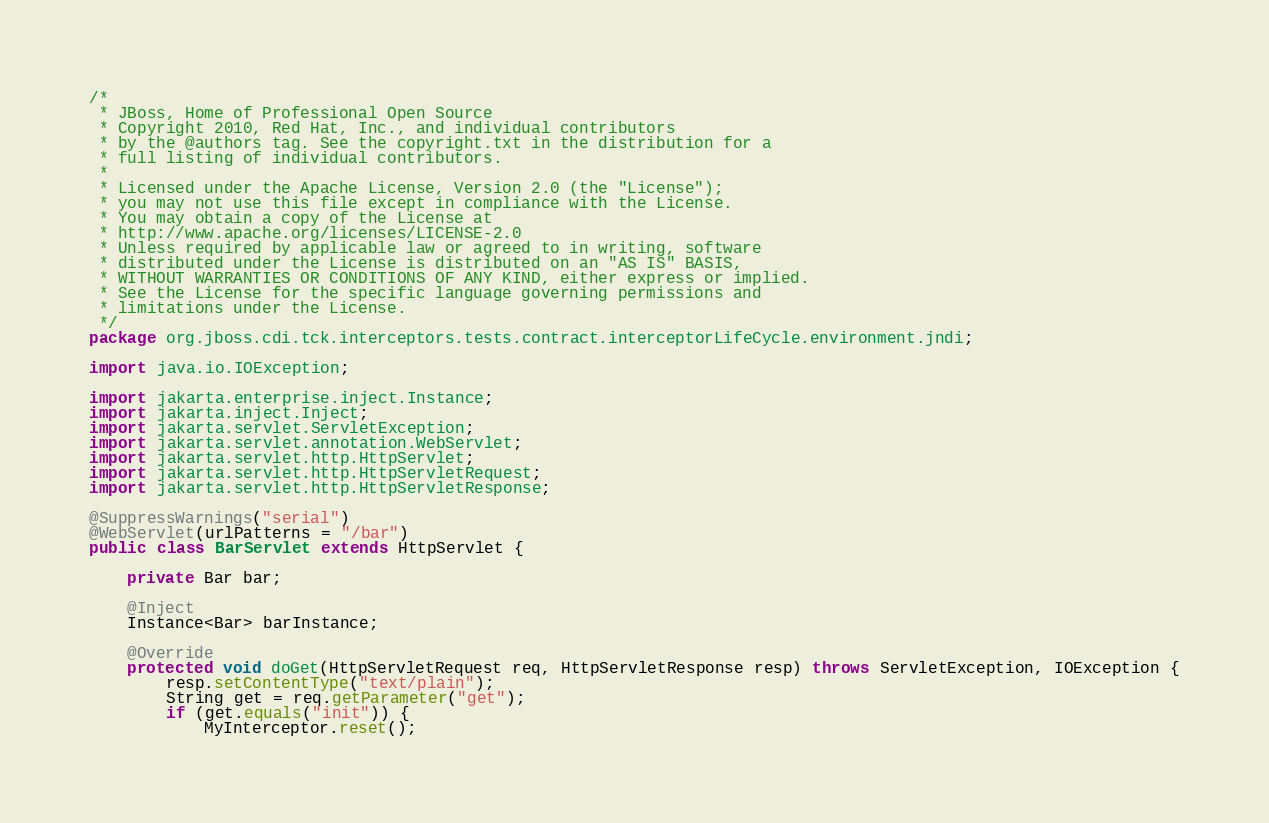<code> <loc_0><loc_0><loc_500><loc_500><_Java_>/*
 * JBoss, Home of Professional Open Source
 * Copyright 2010, Red Hat, Inc., and individual contributors
 * by the @authors tag. See the copyright.txt in the distribution for a
 * full listing of individual contributors.
 *
 * Licensed under the Apache License, Version 2.0 (the "License");
 * you may not use this file except in compliance with the License.
 * You may obtain a copy of the License at
 * http://www.apache.org/licenses/LICENSE-2.0
 * Unless required by applicable law or agreed to in writing, software
 * distributed under the License is distributed on an "AS IS" BASIS,
 * WITHOUT WARRANTIES OR CONDITIONS OF ANY KIND, either express or implied.
 * See the License for the specific language governing permissions and
 * limitations under the License.
 */
package org.jboss.cdi.tck.interceptors.tests.contract.interceptorLifeCycle.environment.jndi;

import java.io.IOException;

import jakarta.enterprise.inject.Instance;
import jakarta.inject.Inject;
import jakarta.servlet.ServletException;
import jakarta.servlet.annotation.WebServlet;
import jakarta.servlet.http.HttpServlet;
import jakarta.servlet.http.HttpServletRequest;
import jakarta.servlet.http.HttpServletResponse;

@SuppressWarnings("serial")
@WebServlet(urlPatterns = "/bar")
public class BarServlet extends HttpServlet {

    private Bar bar;

    @Inject
    Instance<Bar> barInstance;

    @Override
    protected void doGet(HttpServletRequest req, HttpServletResponse resp) throws ServletException, IOException {
        resp.setContentType("text/plain");
        String get = req.getParameter("get");
        if (get.equals("init")) {
            MyInterceptor.reset();</code> 